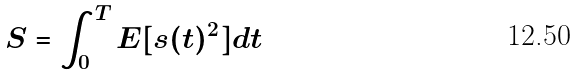<formula> <loc_0><loc_0><loc_500><loc_500>S = \int _ { 0 } ^ { T } E [ s ( t ) ^ { 2 } ] d t</formula> 